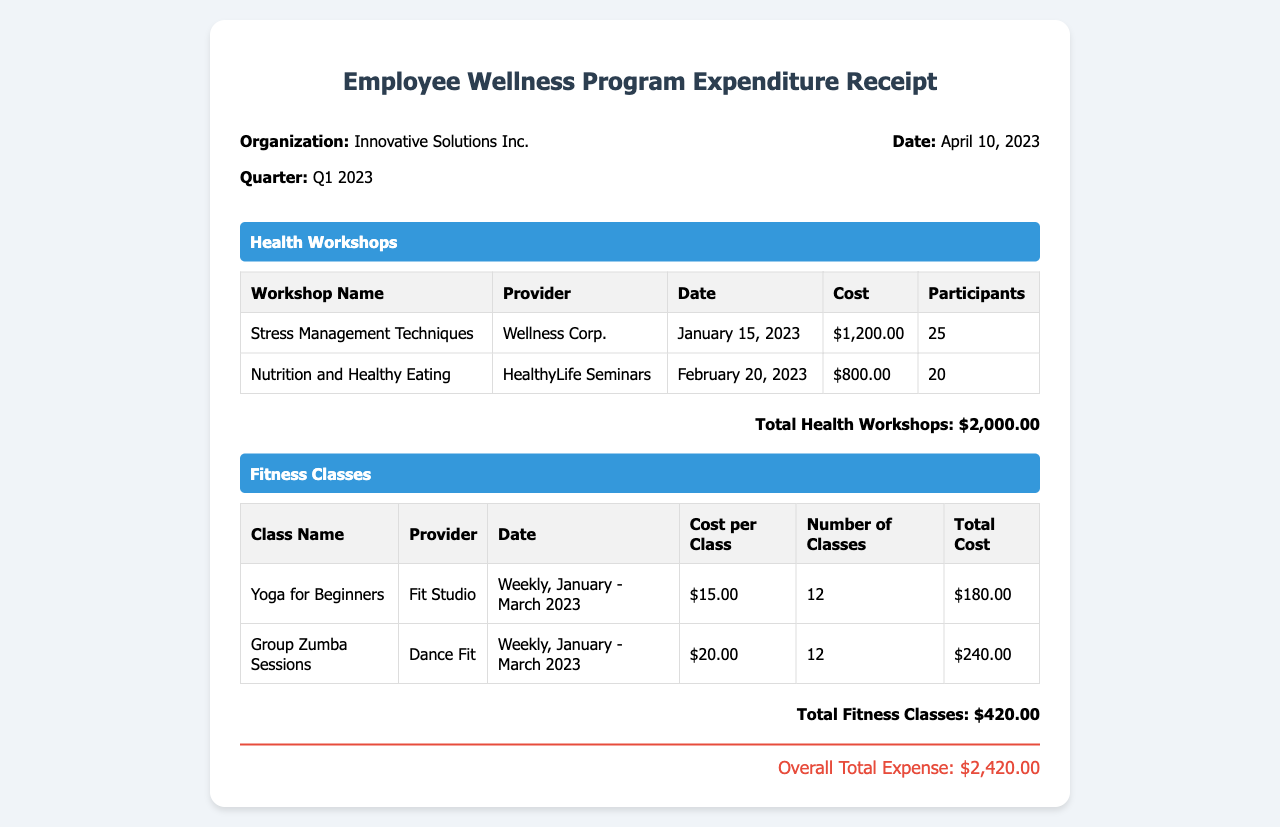What is the total expenditure for health workshops? The total expenditure for health workshops is listed at the bottom of the health workshops table.
Answer: $2,000.00 Who provided the "Nutrition and Healthy Eating" workshop? The provider for the "Nutrition and Healthy Eating" workshop is indicated in the corresponding row of the health workshops table.
Answer: HealthyLife Seminars How many participants attended the "Stress Management Techniques" workshop? The number of participants for the "Stress Management Techniques" workshop is shown in the health workshops table.
Answer: 25 What is the total cost for fitness classes? The total cost for fitness classes is provided at the bottom of the fitness classes table.
Answer: $420.00 How many classes were conducted for "Yoga for Beginners"? The number of classes is detailed in the corresponding row of the fitness classes table.
Answer: 12 What was the total overall expense for the Employee Wellness Program? The overall total expense aggregates all costs and is found at the end of the document.
Answer: $2,420.00 When was the "Stress Management Techniques" workshop held? The date for the "Stress Management Techniques" workshop is specified alongside other details in the health workshops table.
Answer: January 15, 2023 What is the cost per class for "Group Zumba Sessions"? The cost per class is listed in the fitness classes table.
Answer: $20.00 What is the name of the organization mentioned in the receipt? The name of the organization appears prominently at the top of the receipt.
Answer: Innovative Solutions Inc 